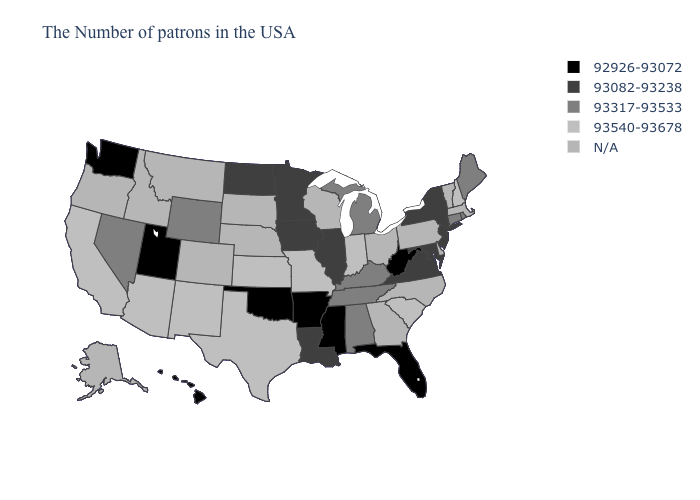Name the states that have a value in the range 93540-93678?
Write a very short answer. New Hampshire, South Carolina, Indiana, Missouri, Kansas, Texas, New Mexico, Arizona, California. What is the value of Maine?
Short answer required. 93317-93533. Does Wyoming have the highest value in the USA?
Answer briefly. No. What is the value of Utah?
Give a very brief answer. 92926-93072. Among the states that border Texas , which have the highest value?
Short answer required. New Mexico. What is the lowest value in the USA?
Answer briefly. 92926-93072. What is the highest value in the USA?
Give a very brief answer. 93540-93678. What is the value of Nebraska?
Answer briefly. N/A. Which states have the lowest value in the USA?
Concise answer only. West Virginia, Florida, Mississippi, Arkansas, Oklahoma, Utah, Washington, Hawaii. Does Rhode Island have the highest value in the Northeast?
Concise answer only. No. Among the states that border Pennsylvania , which have the highest value?
Be succinct. New York, New Jersey, Maryland. Name the states that have a value in the range 93082-93238?
Keep it brief. New York, New Jersey, Maryland, Virginia, Illinois, Louisiana, Minnesota, Iowa, North Dakota. Does the first symbol in the legend represent the smallest category?
Answer briefly. Yes. What is the value of Ohio?
Answer briefly. N/A. 